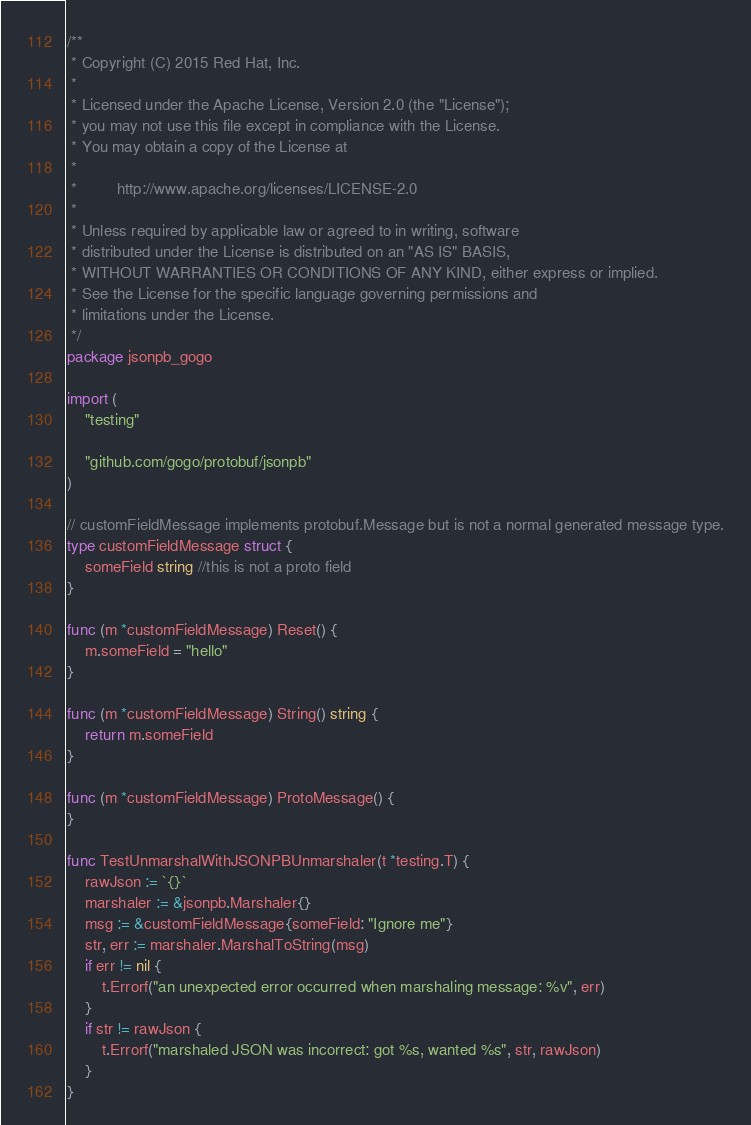Convert code to text. <code><loc_0><loc_0><loc_500><loc_500><_Go_>/**
 * Copyright (C) 2015 Red Hat, Inc.
 *
 * Licensed under the Apache License, Version 2.0 (the "License");
 * you may not use this file except in compliance with the License.
 * You may obtain a copy of the License at
 *
 *         http://www.apache.org/licenses/LICENSE-2.0
 *
 * Unless required by applicable law or agreed to in writing, software
 * distributed under the License is distributed on an "AS IS" BASIS,
 * WITHOUT WARRANTIES OR CONDITIONS OF ANY KIND, either express or implied.
 * See the License for the specific language governing permissions and
 * limitations under the License.
 */
package jsonpb_gogo

import (
	"testing"

	"github.com/gogo/protobuf/jsonpb"
)

// customFieldMessage implements protobuf.Message but is not a normal generated message type.
type customFieldMessage struct {
	someField string //this is not a proto field
}

func (m *customFieldMessage) Reset() {
	m.someField = "hello"
}

func (m *customFieldMessage) String() string {
	return m.someField
}

func (m *customFieldMessage) ProtoMessage() {
}

func TestUnmarshalWithJSONPBUnmarshaler(t *testing.T) {
	rawJson := `{}`
	marshaler := &jsonpb.Marshaler{}
	msg := &customFieldMessage{someField: "Ignore me"}
	str, err := marshaler.MarshalToString(msg)
	if err != nil {
		t.Errorf("an unexpected error occurred when marshaling message: %v", err)
	}
	if str != rawJson {
		t.Errorf("marshaled JSON was incorrect: got %s, wanted %s", str, rawJson)
	}
}
</code> 